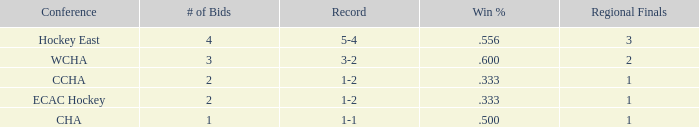What is the sum of the win percentages in the hockey east conference when there are less than 4 bids? 0.0. 